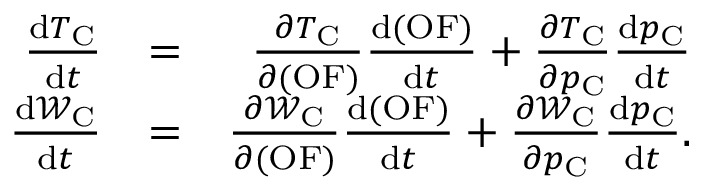Convert formula to latex. <formula><loc_0><loc_0><loc_500><loc_500>\begin{array} { r l r } { \frac { d T _ { C } } { d t } } & { = } & { \frac { \partial T _ { C } } { \partial ( O F ) } \frac { d ( O F ) } { d t } + \frac { \partial T _ { C } } { \partial p _ { C } } \frac { d p _ { C } } { d t } } \\ { \frac { d \mathcal { W } _ { C } } { d t } } & { = } & { \frac { \partial \mathcal { W } _ { C } } { \partial ( O F ) } \frac { d ( O F ) } { d t } + \frac { \partial \mathcal { W } _ { C } } { \partial p _ { C } } \frac { d p _ { C } } { d t } . } \end{array}</formula> 